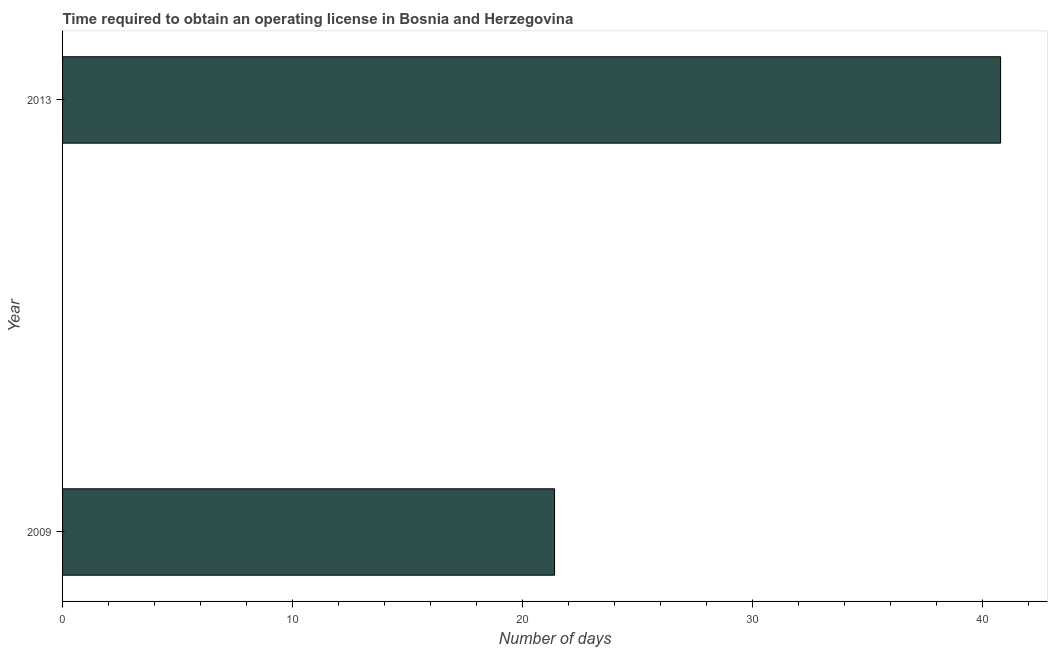Does the graph contain any zero values?
Provide a short and direct response. No. What is the title of the graph?
Offer a terse response. Time required to obtain an operating license in Bosnia and Herzegovina. What is the label or title of the X-axis?
Give a very brief answer. Number of days. What is the label or title of the Y-axis?
Provide a succinct answer. Year. What is the number of days to obtain operating license in 2009?
Make the answer very short. 21.4. Across all years, what is the maximum number of days to obtain operating license?
Offer a terse response. 40.8. Across all years, what is the minimum number of days to obtain operating license?
Give a very brief answer. 21.4. In which year was the number of days to obtain operating license maximum?
Give a very brief answer. 2013. What is the sum of the number of days to obtain operating license?
Offer a terse response. 62.2. What is the difference between the number of days to obtain operating license in 2009 and 2013?
Ensure brevity in your answer.  -19.4. What is the average number of days to obtain operating license per year?
Provide a short and direct response. 31.1. What is the median number of days to obtain operating license?
Ensure brevity in your answer.  31.1. In how many years, is the number of days to obtain operating license greater than 40 days?
Offer a very short reply. 1. What is the ratio of the number of days to obtain operating license in 2009 to that in 2013?
Offer a very short reply. 0.53. How many bars are there?
Your response must be concise. 2. Are all the bars in the graph horizontal?
Your response must be concise. Yes. What is the Number of days in 2009?
Provide a succinct answer. 21.4. What is the Number of days of 2013?
Your answer should be very brief. 40.8. What is the difference between the Number of days in 2009 and 2013?
Give a very brief answer. -19.4. What is the ratio of the Number of days in 2009 to that in 2013?
Give a very brief answer. 0.53. 